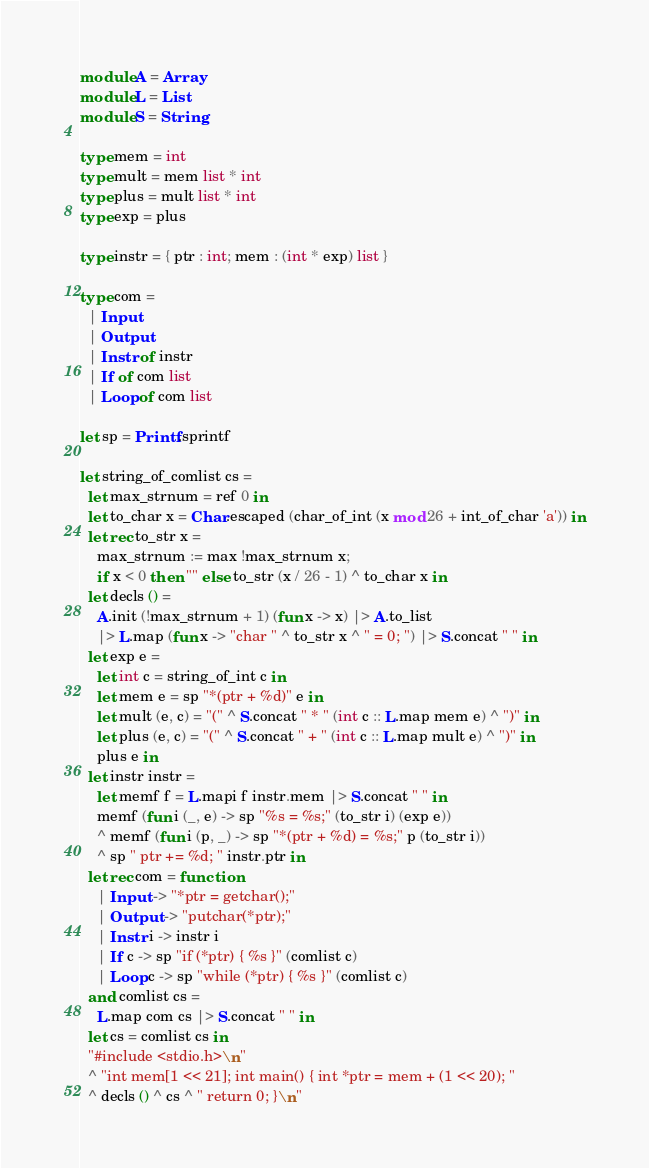Convert code to text. <code><loc_0><loc_0><loc_500><loc_500><_OCaml_>module A = Array
module L = List
module S = String

type mem = int
type mult = mem list * int
type plus = mult list * int
type exp = plus

type instr = { ptr : int; mem : (int * exp) list }

type com =
  | Input
  | Output
  | Instr of instr
  | If of com list
  | Loop of com list

let sp = Printf.sprintf

let string_of_comlist cs =
  let max_strnum = ref 0 in
  let to_char x = Char.escaped (char_of_int (x mod 26 + int_of_char 'a')) in
  let rec to_str x =
    max_strnum := max !max_strnum x;
    if x < 0 then "" else to_str (x / 26 - 1) ^ to_char x in
  let decls () =
    A.init (!max_strnum + 1) (fun x -> x) |> A.to_list
    |> L.map (fun x -> "char " ^ to_str x ^ " = 0; ") |> S.concat " " in
  let exp e =
    let int c = string_of_int c in
    let mem e = sp "*(ptr + %d)" e in
    let mult (e, c) = "(" ^ S.concat " * " (int c :: L.map mem e) ^ ")" in
    let plus (e, c) = "(" ^ S.concat " + " (int c :: L.map mult e) ^ ")" in
    plus e in
  let instr instr =
    let memf f = L.mapi f instr.mem |> S.concat " " in
    memf (fun i (_, e) -> sp "%s = %s;" (to_str i) (exp e))
    ^ memf (fun i (p, _) -> sp "*(ptr + %d) = %s;" p (to_str i))
    ^ sp " ptr += %d; " instr.ptr in
  let rec com = function
    | Input -> "*ptr = getchar();"
    | Output -> "putchar(*ptr);"
    | Instr i -> instr i
    | If c -> sp "if (*ptr) { %s }" (comlist c)
    | Loop c -> sp "while (*ptr) { %s }" (comlist c)
  and comlist cs =
    L.map com cs |> S.concat " " in
  let cs = comlist cs in
  "#include <stdio.h>\n"
  ^ "int mem[1 << 21]; int main() { int *ptr = mem + (1 << 20); "
  ^ decls () ^ cs ^ " return 0; }\n"
</code> 